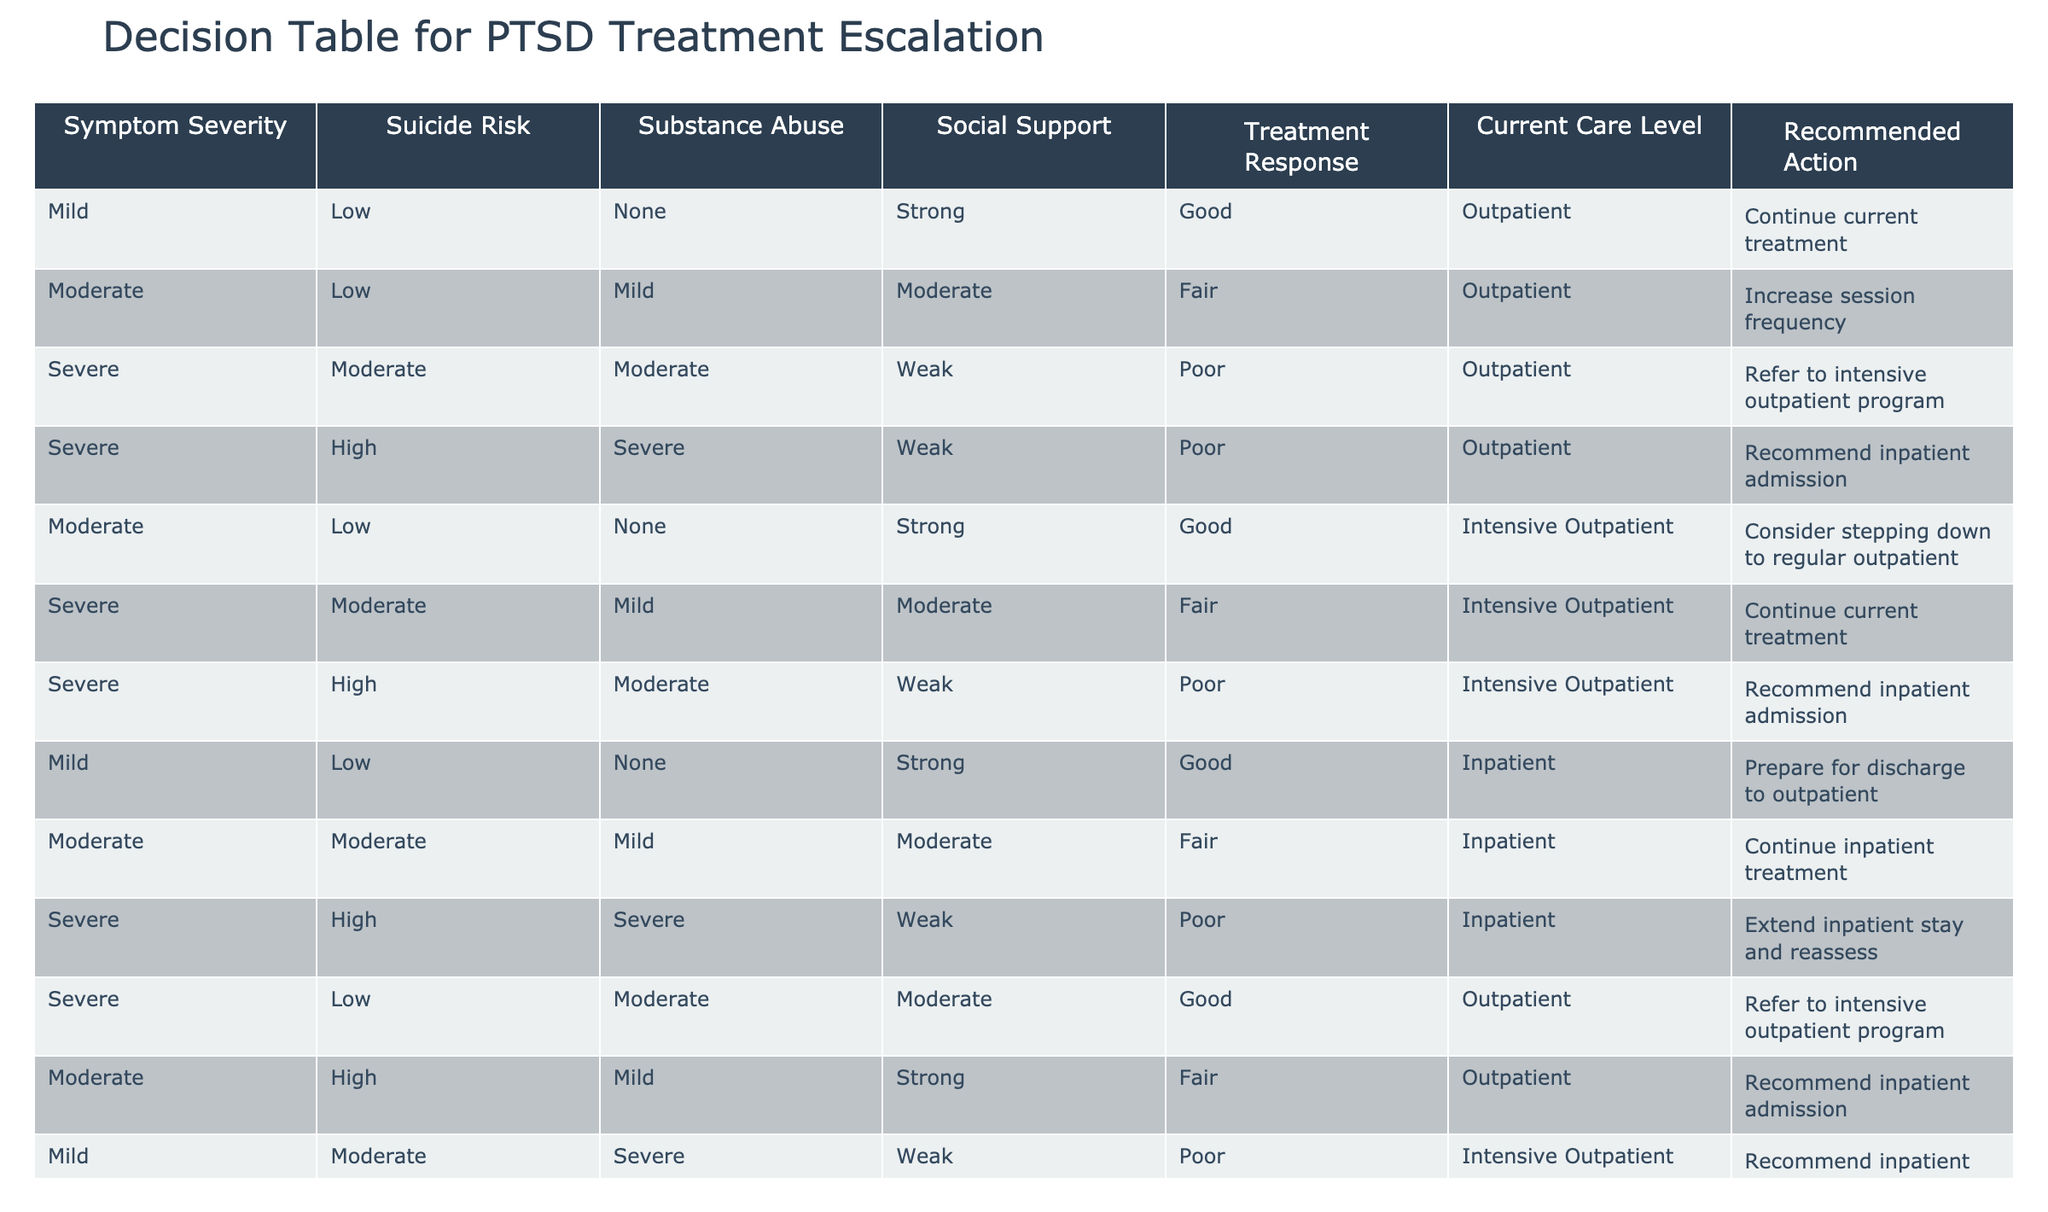What is the recommended action for a veteran with severe PTSD symptoms, high suicide risk, and severe substance abuse in outpatient care? The row that fits these criteria shows the situation where "Severe" symptom severity, "High" suicide risk, "Severe" substance abuse, and "Outpatient" current care level leads to the recommendation of "Recommend inpatient admission."
Answer: Recommend inpatient admission What is the current care level for a veteran who shows moderate symptoms with low suicide risk and strong social support? By checking the corresponding row for "Moderate" symptom severity, "Low" suicide risk, and "Strong" social support, we see that the current care level in this case is "Outpatient."
Answer: Outpatient Is there a recommendation to continue treatment when the treatment response is poor? Reviewing the table, several cases with a "Poor" treatment response indicate a referral to other care levels rather than continuing current treatment, particularly when severity or other risk factors are high. Therefore, the answer to this question is "No."
Answer: No How many cases recommended inpatient admission when the current care level was outpatient? Counting the relevant cases from the table, we find that there are three situations where the recommended action was to "Recommend inpatient admission," and all of them had "Outpatient" as the current care level.
Answer: 3 What is the recommended action when a veteran with severe PTSD has moderate suicide risk and is currently in intensive outpatient care? The relevant row for "Severe" PTSD symptoms, "Moderate" suicide risk, and "Intensive Outpatient" care shows that the recommended action in this case is to "Continue current treatment."
Answer: Continue current treatment What is the relationship between treatment response and recommended actions for cases with severe PTSD symptoms? Analyzing the cases with "Severe" symptom severity, the outcome shows that "Poor" treatment responses lead to either a recommendation for an inpatient stay or an extension of inpatient care, whereas "Fair" responses lead to "Continue current treatment" or "Refer to intensive outpatient program."
Answer: Poor treatment leads to more escalated actions Which group has the lowest current care level among the "Severe" cases in the table? By examining the rows with "Severe" symptom severity, the current care levels listed are mostly either "Outpatient" or "Intensive Outpatient," leading to the conclusion that "Outpatient" is the lowest level documented in this context.
Answer: Outpatient 